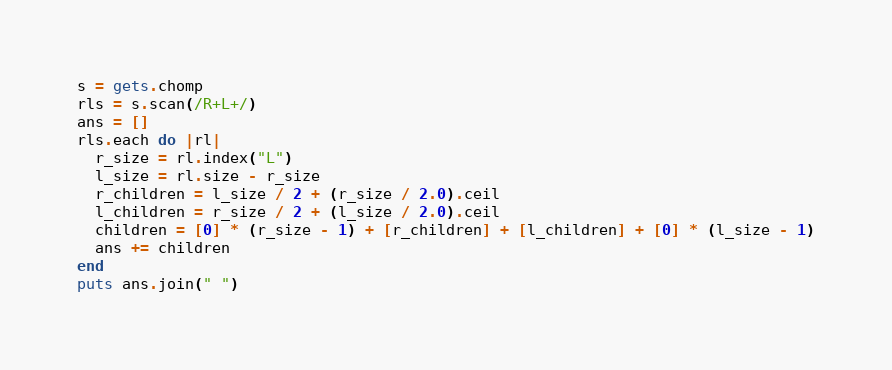<code> <loc_0><loc_0><loc_500><loc_500><_Ruby_>s = gets.chomp
rls = s.scan(/R+L+/)
ans = []
rls.each do |rl|
  r_size = rl.index("L")
  l_size = rl.size - r_size
  r_children = l_size / 2 + (r_size / 2.0).ceil
  l_children = r_size / 2 + (l_size / 2.0).ceil
  children = [0] * (r_size - 1) + [r_children] + [l_children] + [0] * (l_size - 1)
  ans += children
end
puts ans.join(" ")
</code> 